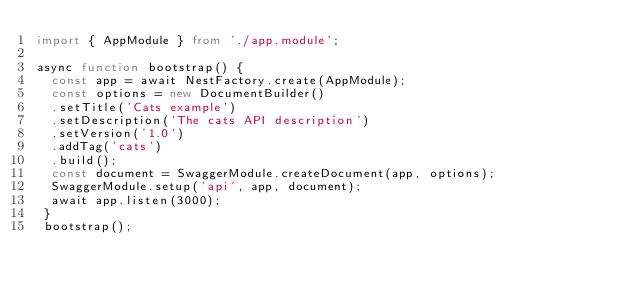<code> <loc_0><loc_0><loc_500><loc_500><_TypeScript_>import { AppModule } from './app.module';

async function bootstrap() {
  const app = await NestFactory.create(AppModule);
  const options = new DocumentBuilder()
  .setTitle('Cats example')
  .setDescription('The cats API description')
  .setVersion('1.0')
  .addTag('cats')
  .build();
  const document = SwaggerModule.createDocument(app, options);
  SwaggerModule.setup('api', app, document);
  await app.listen(3000);
 }
 bootstrap();
</code> 